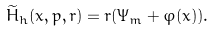<formula> <loc_0><loc_0><loc_500><loc_500>\widetilde { H } _ { h } ( x , p , r ) = r ( \Psi _ { m } + \varphi ( x ) ) .</formula> 